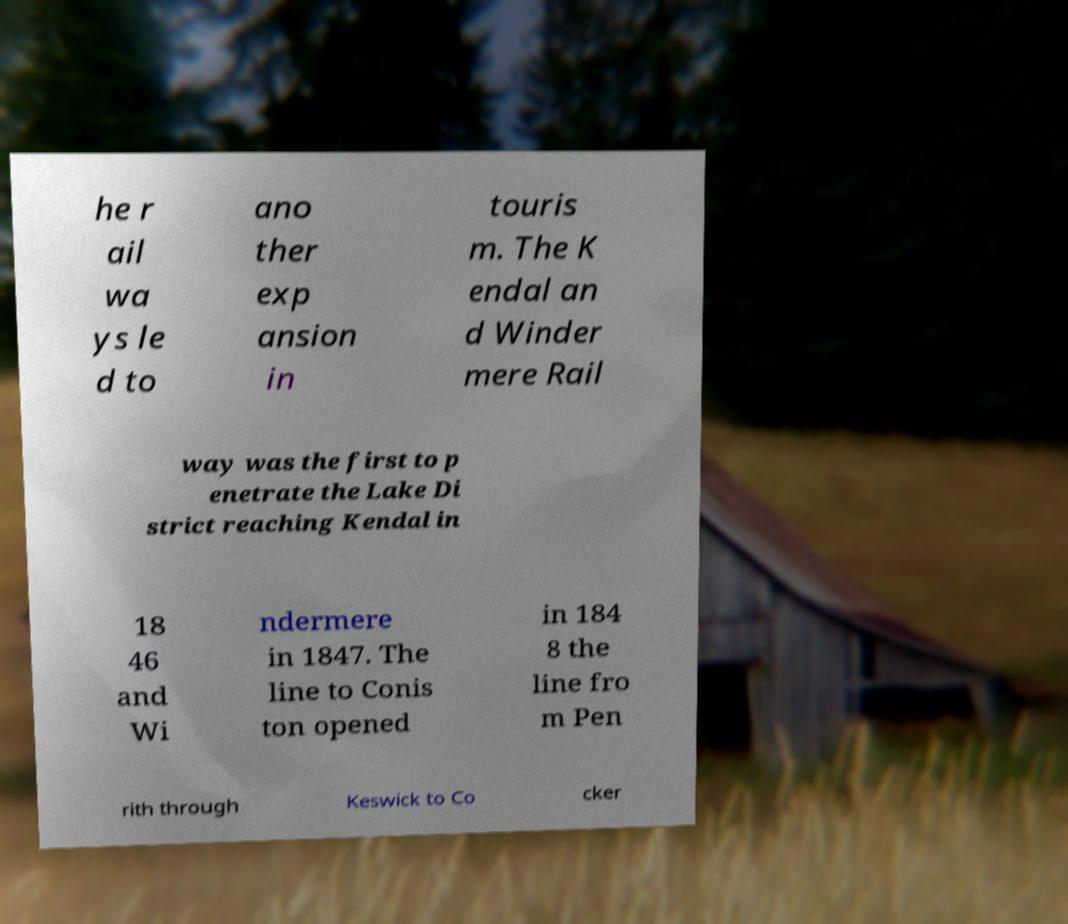Can you read and provide the text displayed in the image?This photo seems to have some interesting text. Can you extract and type it out for me? he r ail wa ys le d to ano ther exp ansion in touris m. The K endal an d Winder mere Rail way was the first to p enetrate the Lake Di strict reaching Kendal in 18 46 and Wi ndermere in 1847. The line to Conis ton opened in 184 8 the line fro m Pen rith through Keswick to Co cker 